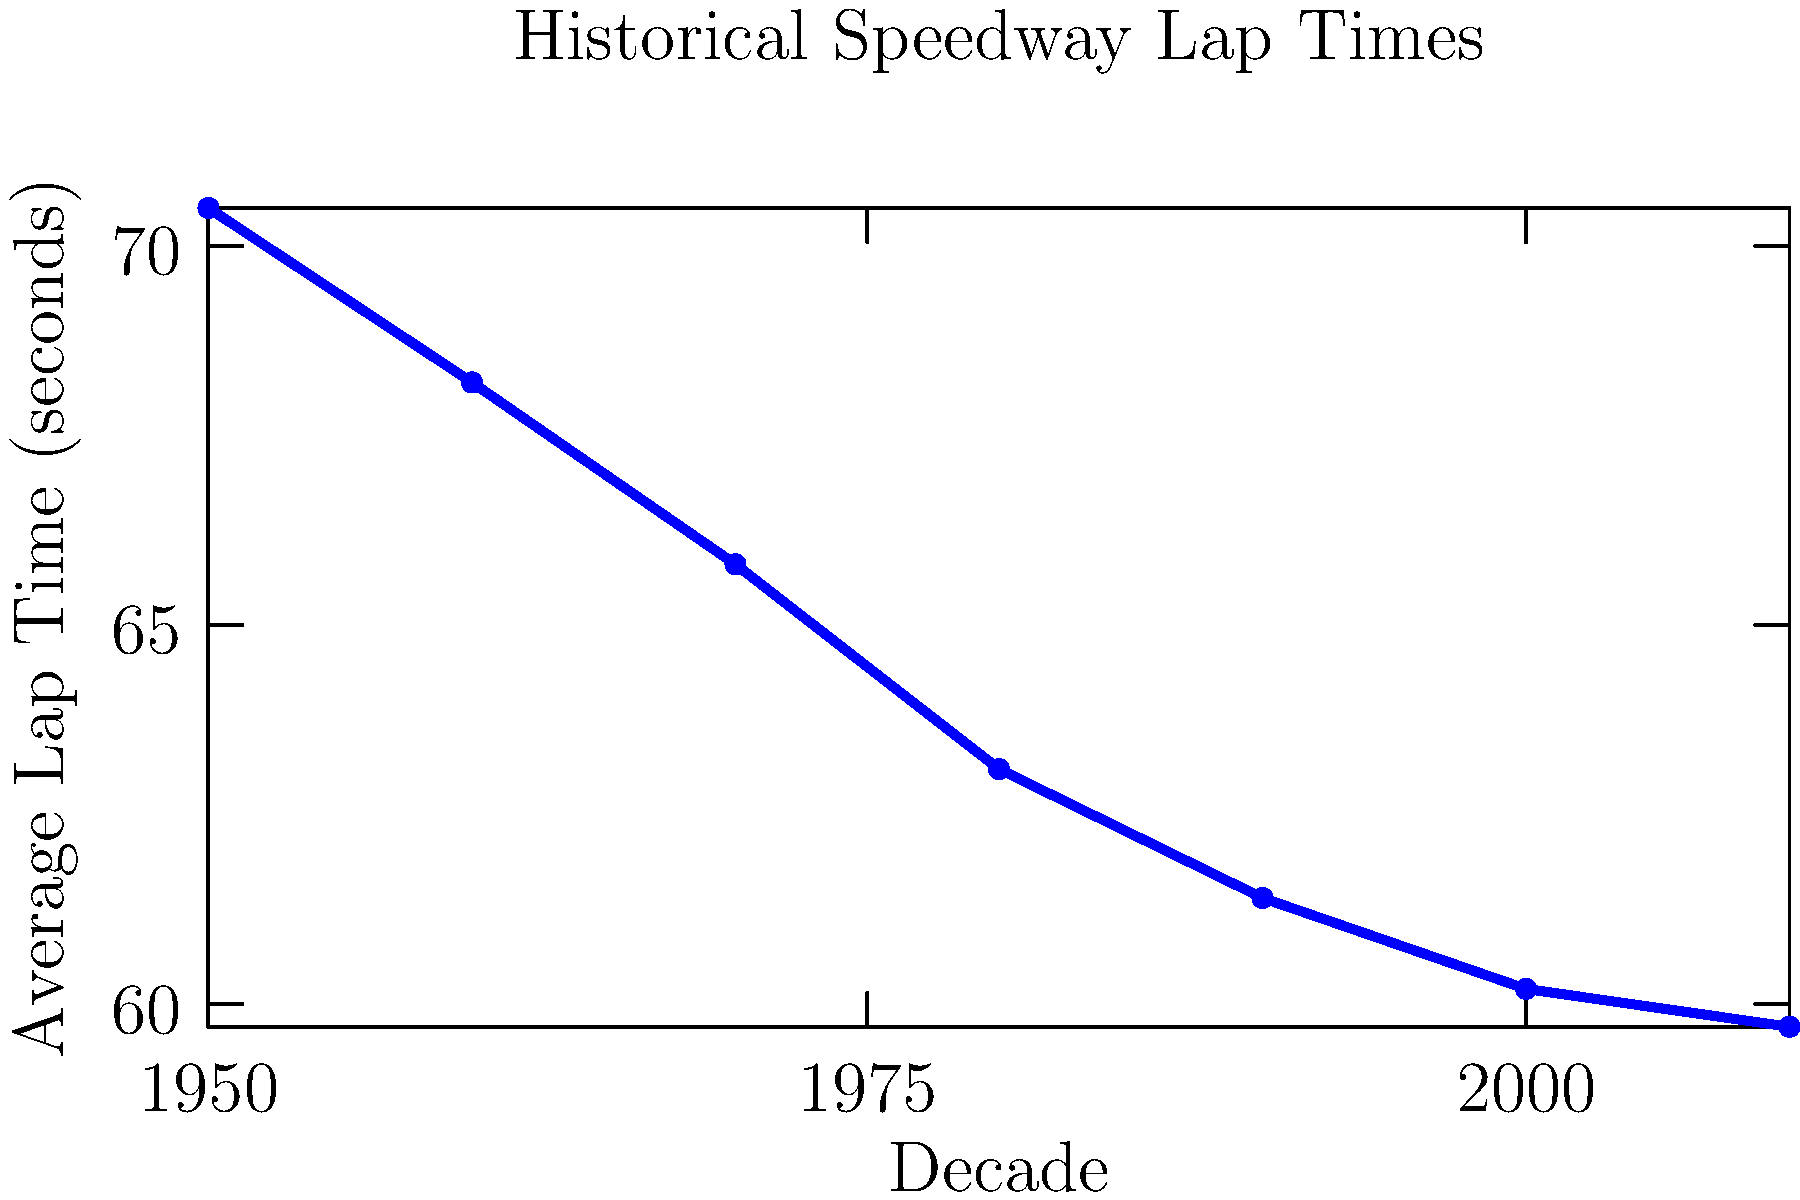Based on the graph showing historical speedway lap times across different decades, calculate the average rate of improvement in lap times per decade between 1950 and 2010. Express your answer in seconds per decade, rounded to two decimal places. To solve this problem, we'll follow these steps:

1. Identify the initial and final lap times:
   - 1950 lap time: 70.5 seconds
   - 2010 lap time: 59.7 seconds

2. Calculate the total improvement in lap times:
   $70.5 - 59.7 = 10.8$ seconds

3. Determine the number of decades between 1950 and 2010:
   $(2010 - 1950) / 10 = 6$ decades

4. Calculate the average improvement per decade:
   $10.8 \text{ seconds} / 6 \text{ decades} = 1.8 \text{ seconds per decade}$

5. Round the result to two decimal places:
   1.8 seconds per decade (already in two decimal places)

Therefore, the average rate of improvement in lap times per decade between 1950 and 2010 is 1.8 seconds per decade.
Answer: 1.8 seconds per decade 